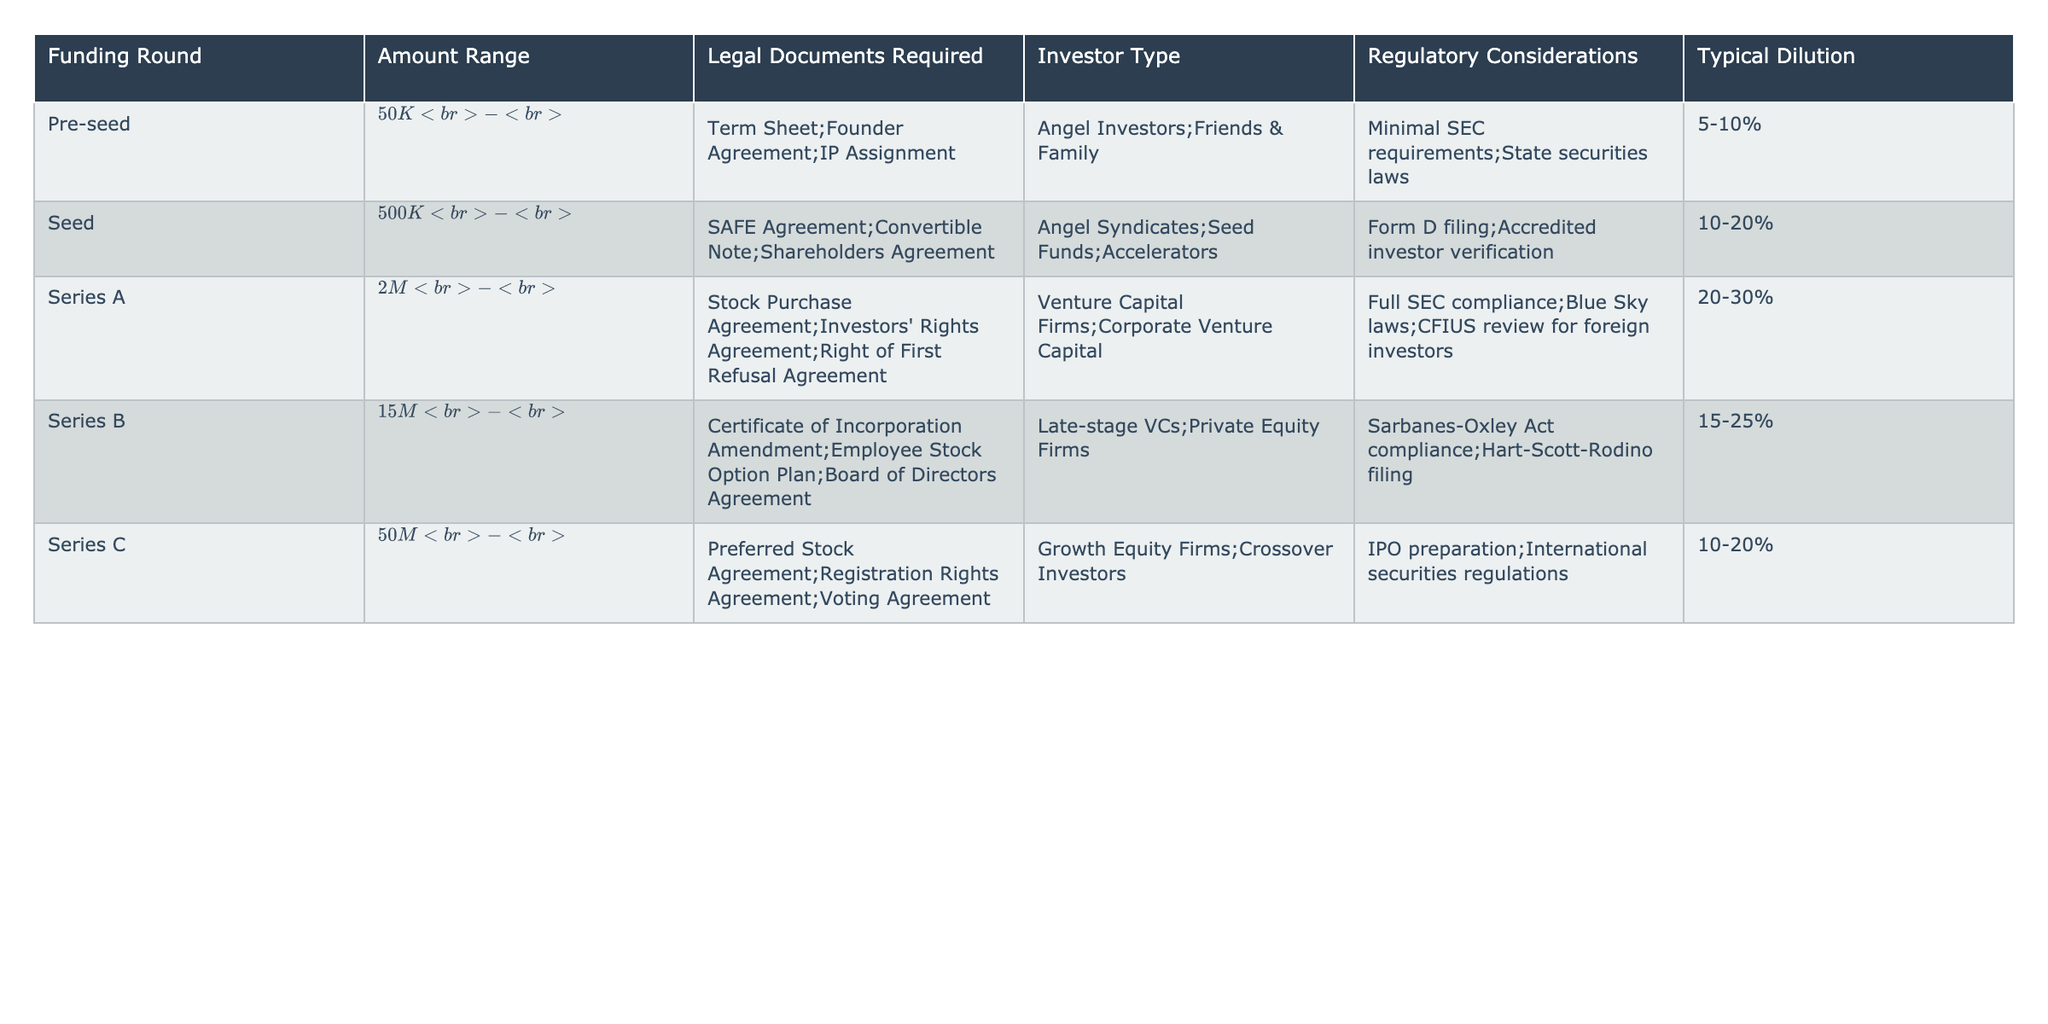What is the amount range for the Series A funding round? The table lists the amount range for Series A as $2M - $15M.
Answer: $2M - $15M Which investor type is associated with the Seed funding round? According to the table, the investor types for the Seed round include Angel Syndicates, Seed Funds, and Accelerators.
Answer: Angel Syndicates, Seed Funds, Accelerators What is the typical dilution percentage for the Series B funding round? The table indicates that the typical dilution for Series B is 15-25%.
Answer: 15-25% Does the Series C funding round require a Stock Purchase Agreement? The table shows that Series C funding includes a Preferred Stock Agreement, but not specifically a Stock Purchase Agreement. Therefore, the answer is no.
Answer: No What is the typical dilution percentage range from Pre-seed to Series C rounds? We take the typical dilutions from each round: Pre-seed (5-10%), Seed (10-20%), Series A (20-30%), Series B (15-25%), and Series C (10-20%). The average is found by aggregating these ranges. Since there is variation, the overall range from lowest to highest dilutions collectively is 5-30%. Therefore, the typical dilution percentage range from Pre-seed to Series C is 5-30%.
Answer: 5-30% Which funding round has the highest minimum amount range and what is that amount? The Series A funding round has the highest minimum amount range at $2M, compared to pre-seed ($50K) and Seed ($500K).
Answer: $2M What legal documents are generally required for the Seed funding round? The legal documents required for the Seed funding round, according to the table, are SAFE Agreement, Convertible Note, and Shareholders Agreement.
Answer: SAFE Agreement; Convertible Note; Shareholders Agreement If a startup raises $30M, which funding rounds does it fall into, and what are the required legal documents? $30M falls into the Series B round since the range is $15M - $50M. The legal documents required for Series B are Certificate of Incorporation Amendment, Employee Stock Option Plan, and Board of Directors Agreement.
Answer: Series B; Certificate of Incorporation Amendment; Employee Stock Option Plan; Board of Directors Agreement What are the regulatory considerations for Series A funding? The regulatory considerations listed for Series A funding in the table are full SEC compliance, Blue Sky laws, and CFIUS review for foreign investors.
Answer: Full SEC compliance; Blue Sky laws; CFIUS review for foreign investors Which funding round has the lowest upper limit on the amount range? The Pre-seed funding round has the lowest upper limit at $500K, as the Seed round starts from $500K - $2M.
Answer: Pre-seed Are there more legal documents required in later rounds than in earlier rounds? If we compare the number of legal documents required in each round from Pre-seed to Series C, we see growth in the number of legal requirements, indicating that later rounds generally require more documentation. Thus, the answer is yes.
Answer: Yes 